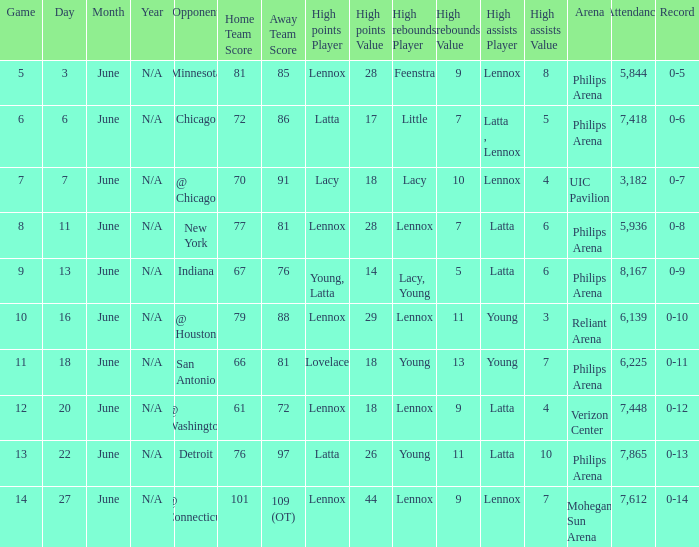Could you parse the entire table as a dict? {'header': ['Game', 'Day', 'Month', 'Year', 'Opponent', 'Home Team Score', 'Away Team Score', 'High points Player', 'High points Value', 'High rebounds Player', 'High rebounds Value', 'High assists Player', 'High assists Value', 'Arena', 'Attendance', 'Record'], 'rows': [['5', '3', 'June', 'N/A', 'Minnesota', '81', '85', 'Lennox', '28', 'Feenstra', '9', 'Lennox', '8', 'Philips Arena', '5,844', '0-5'], ['6', '6', 'June', 'N/A', 'Chicago', '72', '86', 'Latta', '17', 'Little', '7', 'Latta , Lennox', '5', 'Philips Arena', '7,418', '0-6'], ['7', '7', 'June', 'N/A', '@ Chicago', '70', '91', 'Lacy', '18', 'Lacy', '10', 'Lennox', '4', 'UIC Pavilion', '3,182', '0-7'], ['8', '11', 'June', 'N/A', 'New York', '77', '81', 'Lennox', '28', 'Lennox', '7', 'Latta', '6', 'Philips Arena', '5,936', '0-8'], ['9', '13', 'June', 'N/A', 'Indiana', '67', '76', 'Young, Latta', '14', 'Lacy, Young', '5', 'Latta', '6', 'Philips Arena', '8,167', '0-9'], ['10', '16', 'June', 'N/A', '@ Houston', '79', '88', 'Lennox', '29', 'Lennox', '11', 'Young', '3', 'Reliant Arena', '6,139', '0-10'], ['11', '18', 'June', 'N/A', 'San Antonio', '66', '81', 'Lovelace', '18', 'Young', '13', 'Young', '7', 'Philips Arena', '6,225', '0-11'], ['12', '20', 'June', 'N/A', '@ Washington', '61', '72', 'Lennox', '18', 'Lennox', '9', 'Latta', '4', 'Verizon Center', '7,448', '0-12'], ['13', '22', 'June', 'N/A', 'Detroit', '76', '97', 'Latta', '26', 'Young', '11', 'Latta', '10', 'Philips Arena', '7,865', '0-13'], ['14', '27', 'June', 'N/A', '@ Connecticut', '101', '109 (OT)', 'Lennox', '44', 'Lennox', '9', 'Lennox', '7', 'Mohegan Sun Arena', '7,612', '0-14']]} In which stadium was the june 7 event held, and what was the attendance count? UIC Pavilion 3,182. 